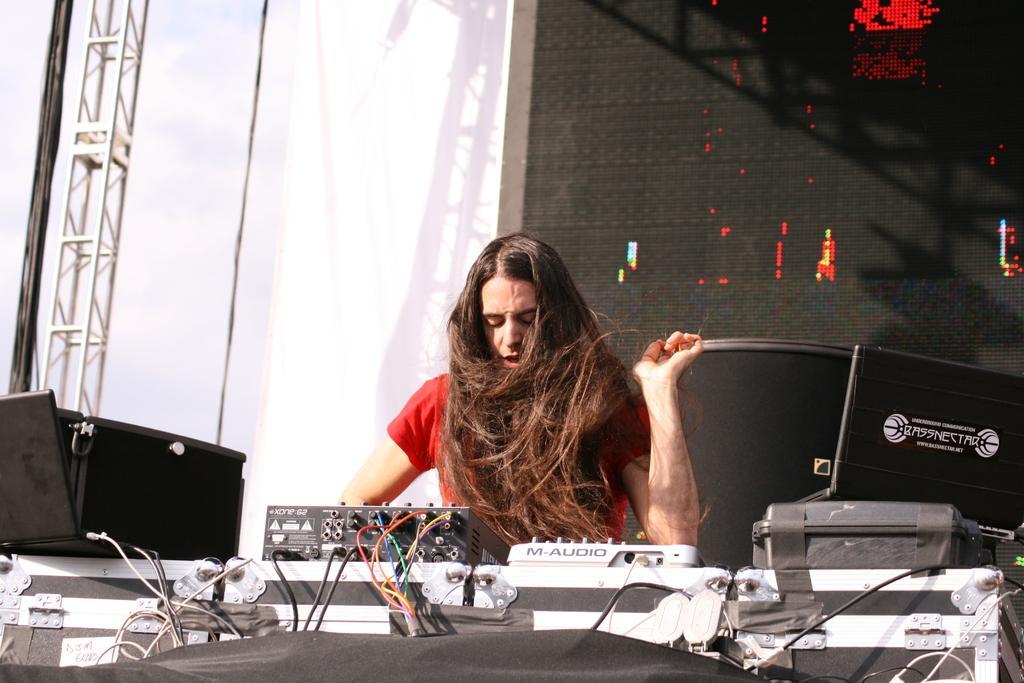Describe this image in one or two sentences. In this image I can see a person wearing red colored dress and I can see few electronic equipment in front of him. I can see few wires and a black colored object in front of him. In the background I can see a screen which is red and black in color, the white colored cloth and the sky. 